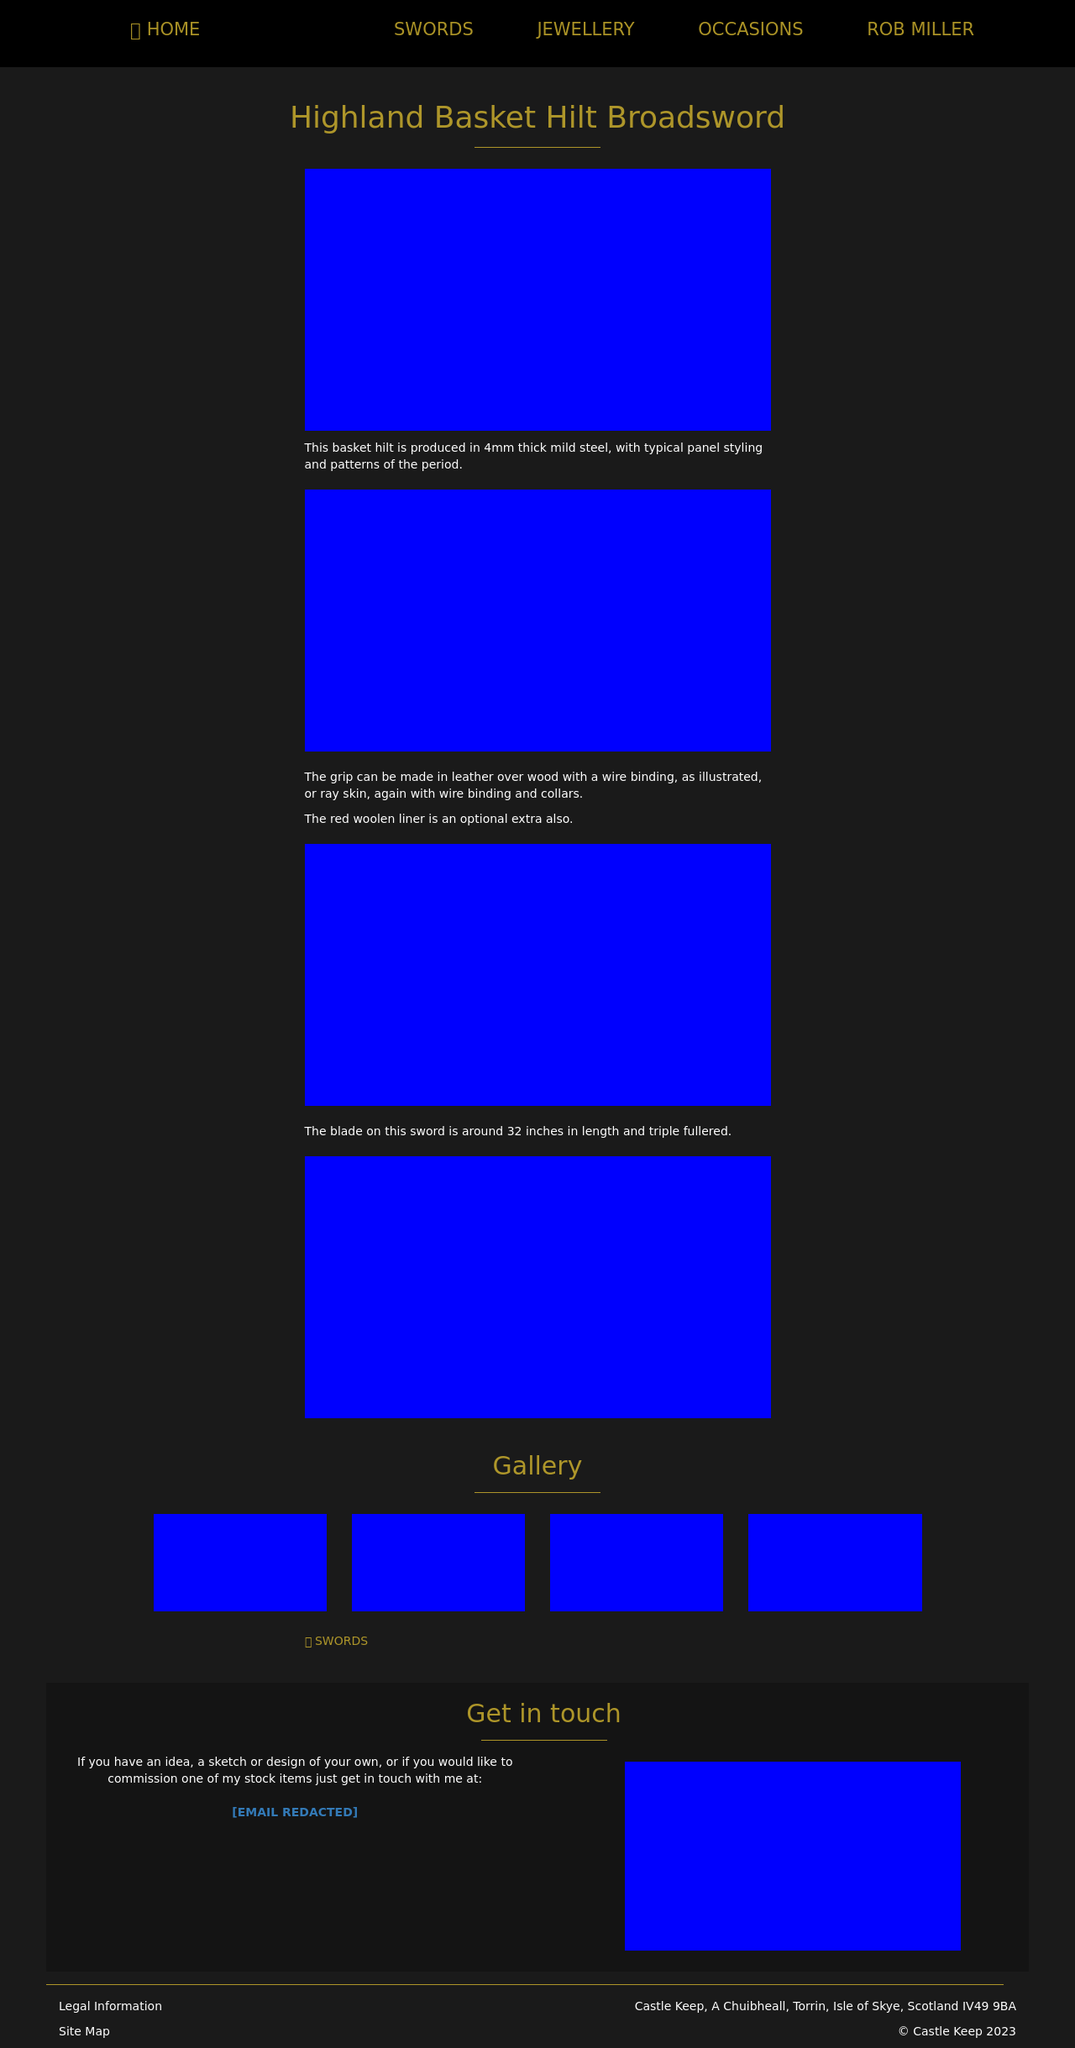How can I start building this website with HTML from the ground up? To start building a website with HTML from scratch, you need to begin with the basics. First, create a new document and save it with a .html extension. Start with the doctype declaration at the top to define the HTML version - typically HTML5 is used today: '<!DOCTYPE html>'. Then, add the root HTML tag and define the head and body sections. Inside the head, commonly include metadata like your charset and the viewport settings to ensure your site is responsive. For example: 

<!DOCTYPE html>
<html>
<head>
  <meta charset='UTF-8'>
  <meta name='viewport' content='width=device-width, initial-scale=1.0'>
  <title>Your Website Title Here</title>
</head>
<body>
  <h1>Hello, welcome to my website!</h1>
  <p>This is a paragraph of text to start off the homepage of your brand new website.</p>
</body>
</html>

This basic structure will serve as the foundation, to which you can add more complex elements like links, images, lists, and CSS for styling. 